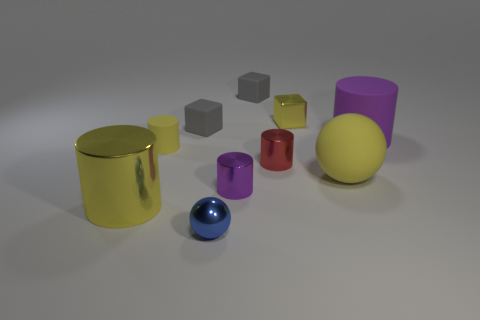What material is the tiny cylinder that is the same color as the large shiny thing?
Offer a very short reply. Rubber. Do the rubber ball and the metallic object that is in front of the large metallic object have the same size?
Your answer should be compact. No. There is a gray object that is right of the blue sphere; what is its shape?
Give a very brief answer. Cube. Is there a tiny metallic thing that is in front of the cylinder that is in front of the small metallic cylinder in front of the big sphere?
Offer a terse response. Yes. There is a big yellow thing that is the same shape as the small blue thing; what material is it?
Your answer should be very brief. Rubber. Are there any other things that are made of the same material as the small blue ball?
Provide a short and direct response. Yes. How many balls are either gray things or yellow metal things?
Provide a short and direct response. 0. Does the matte cylinder that is left of the tiny blue metal ball have the same size as the metal object that is in front of the large yellow metallic object?
Offer a very short reply. Yes. There is a big cylinder that is on the right side of the big thing in front of the yellow matte ball; what is it made of?
Make the answer very short. Rubber. Are there fewer metal spheres that are in front of the red cylinder than small purple rubber cylinders?
Your answer should be very brief. No. 